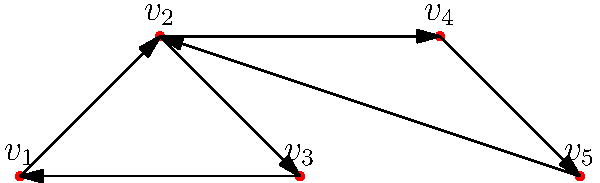Given the directed graph above, identify all strongly connected components (SCCs). How many SCCs are there, and which vertices belong to each component? To identify strongly connected components in a directed graph, we can use Kosaraju's algorithm. Let's follow the steps:

1. Perform a depth-first search (DFS) on the original graph to compute finishing times for each vertex:
   - Start with $v_1$: visit $v_2$, then $v_3$, back to $v_1$
   - Visit $v_4$, then $v_5$, back to $v_2$
   - Finishing order: $v_3$, $v_1$, $v_5$, $v_4$, $v_2$

2. Transpose the graph (reverse all edges):
   $v_2 \rightarrow v_1$, $v_3 \rightarrow v_2$, $v_1 \rightarrow v_3$,
   $v_4 \rightarrow v_2$, $v_5 \rightarrow v_4$, $v_2 \rightarrow v_5$

3. Perform DFS on the transposed graph, starting with the highest finishing time vertex:
   - Start with $v_2$: visit $v_5$, $v_4$, $v_1$, $v_3$
   - All vertices visited in one DFS, forming the first and only SCC

Therefore, there is only one strongly connected component containing all vertices: $\{v_1, v_2, v_3, v_4, v_5\}$.
Answer: 1 SCC: $\{v_1, v_2, v_3, v_4, v_5\}$ 